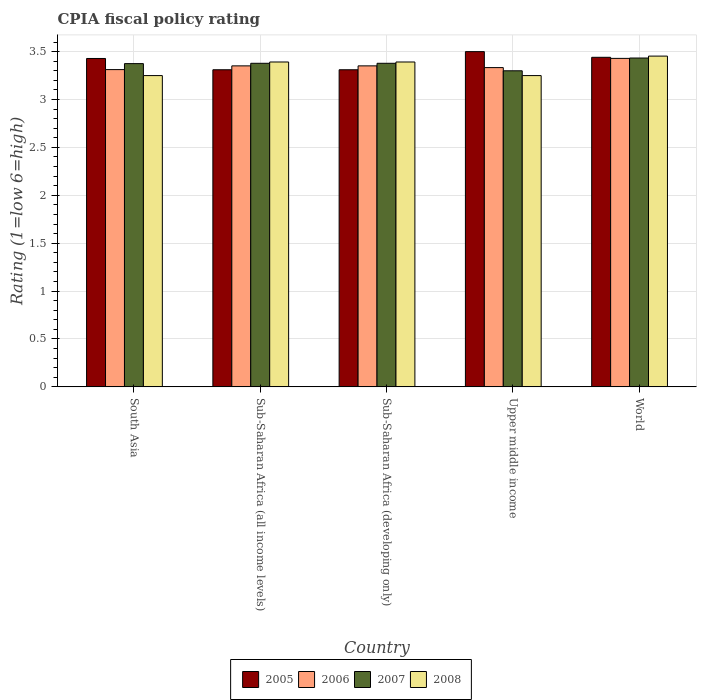Are the number of bars on each tick of the X-axis equal?
Ensure brevity in your answer.  Yes. What is the CPIA rating in 2007 in Sub-Saharan Africa (developing only)?
Offer a very short reply. 3.38. Across all countries, what is the maximum CPIA rating in 2006?
Ensure brevity in your answer.  3.43. Across all countries, what is the minimum CPIA rating in 2005?
Make the answer very short. 3.31. In which country was the CPIA rating in 2006 maximum?
Provide a succinct answer. World. In which country was the CPIA rating in 2007 minimum?
Make the answer very short. Upper middle income. What is the total CPIA rating in 2008 in the graph?
Your answer should be very brief. 16.74. What is the difference between the CPIA rating in 2006 in South Asia and that in Upper middle income?
Your answer should be very brief. -0.02. What is the difference between the CPIA rating in 2006 in Sub-Saharan Africa (developing only) and the CPIA rating in 2005 in World?
Make the answer very short. -0.09. What is the average CPIA rating in 2006 per country?
Your response must be concise. 3.36. What is the difference between the CPIA rating of/in 2005 and CPIA rating of/in 2006 in World?
Offer a very short reply. 0.01. What is the ratio of the CPIA rating in 2007 in South Asia to that in Sub-Saharan Africa (all income levels)?
Make the answer very short. 1. Is the CPIA rating in 2005 in South Asia less than that in Sub-Saharan Africa (all income levels)?
Provide a succinct answer. No. Is the difference between the CPIA rating in 2005 in Sub-Saharan Africa (all income levels) and World greater than the difference between the CPIA rating in 2006 in Sub-Saharan Africa (all income levels) and World?
Make the answer very short. No. What is the difference between the highest and the second highest CPIA rating in 2007?
Keep it short and to the point. -0.05. What is the difference between the highest and the lowest CPIA rating in 2006?
Give a very brief answer. 0.12. In how many countries, is the CPIA rating in 2005 greater than the average CPIA rating in 2005 taken over all countries?
Provide a short and direct response. 3. Is it the case that in every country, the sum of the CPIA rating in 2007 and CPIA rating in 2005 is greater than the sum of CPIA rating in 2008 and CPIA rating in 2006?
Provide a succinct answer. No. Are the values on the major ticks of Y-axis written in scientific E-notation?
Provide a succinct answer. No. Does the graph contain any zero values?
Your answer should be very brief. No. Where does the legend appear in the graph?
Offer a very short reply. Bottom center. How are the legend labels stacked?
Offer a very short reply. Horizontal. What is the title of the graph?
Your answer should be compact. CPIA fiscal policy rating. What is the label or title of the Y-axis?
Give a very brief answer. Rating (1=low 6=high). What is the Rating (1=low 6=high) of 2005 in South Asia?
Offer a terse response. 3.43. What is the Rating (1=low 6=high) in 2006 in South Asia?
Your response must be concise. 3.31. What is the Rating (1=low 6=high) of 2007 in South Asia?
Provide a succinct answer. 3.38. What is the Rating (1=low 6=high) in 2005 in Sub-Saharan Africa (all income levels)?
Keep it short and to the point. 3.31. What is the Rating (1=low 6=high) of 2006 in Sub-Saharan Africa (all income levels)?
Offer a terse response. 3.35. What is the Rating (1=low 6=high) of 2007 in Sub-Saharan Africa (all income levels)?
Your response must be concise. 3.38. What is the Rating (1=low 6=high) of 2008 in Sub-Saharan Africa (all income levels)?
Give a very brief answer. 3.39. What is the Rating (1=low 6=high) in 2005 in Sub-Saharan Africa (developing only)?
Provide a succinct answer. 3.31. What is the Rating (1=low 6=high) of 2006 in Sub-Saharan Africa (developing only)?
Offer a very short reply. 3.35. What is the Rating (1=low 6=high) in 2007 in Sub-Saharan Africa (developing only)?
Give a very brief answer. 3.38. What is the Rating (1=low 6=high) in 2008 in Sub-Saharan Africa (developing only)?
Make the answer very short. 3.39. What is the Rating (1=low 6=high) in 2005 in Upper middle income?
Provide a short and direct response. 3.5. What is the Rating (1=low 6=high) in 2006 in Upper middle income?
Provide a short and direct response. 3.33. What is the Rating (1=low 6=high) in 2008 in Upper middle income?
Provide a short and direct response. 3.25. What is the Rating (1=low 6=high) of 2005 in World?
Ensure brevity in your answer.  3.44. What is the Rating (1=low 6=high) of 2006 in World?
Provide a succinct answer. 3.43. What is the Rating (1=low 6=high) in 2007 in World?
Offer a terse response. 3.43. What is the Rating (1=low 6=high) in 2008 in World?
Your answer should be compact. 3.45. Across all countries, what is the maximum Rating (1=low 6=high) in 2005?
Keep it short and to the point. 3.5. Across all countries, what is the maximum Rating (1=low 6=high) in 2006?
Make the answer very short. 3.43. Across all countries, what is the maximum Rating (1=low 6=high) of 2007?
Your response must be concise. 3.43. Across all countries, what is the maximum Rating (1=low 6=high) in 2008?
Keep it short and to the point. 3.45. Across all countries, what is the minimum Rating (1=low 6=high) of 2005?
Your response must be concise. 3.31. Across all countries, what is the minimum Rating (1=low 6=high) of 2006?
Your response must be concise. 3.31. Across all countries, what is the minimum Rating (1=low 6=high) of 2007?
Provide a succinct answer. 3.3. What is the total Rating (1=low 6=high) in 2005 in the graph?
Offer a very short reply. 16.99. What is the total Rating (1=low 6=high) of 2006 in the graph?
Keep it short and to the point. 16.78. What is the total Rating (1=low 6=high) in 2007 in the graph?
Give a very brief answer. 16.87. What is the total Rating (1=low 6=high) in 2008 in the graph?
Offer a very short reply. 16.74. What is the difference between the Rating (1=low 6=high) of 2005 in South Asia and that in Sub-Saharan Africa (all income levels)?
Your answer should be very brief. 0.12. What is the difference between the Rating (1=low 6=high) of 2006 in South Asia and that in Sub-Saharan Africa (all income levels)?
Your answer should be compact. -0.04. What is the difference between the Rating (1=low 6=high) in 2007 in South Asia and that in Sub-Saharan Africa (all income levels)?
Your response must be concise. -0. What is the difference between the Rating (1=low 6=high) in 2008 in South Asia and that in Sub-Saharan Africa (all income levels)?
Provide a succinct answer. -0.14. What is the difference between the Rating (1=low 6=high) of 2005 in South Asia and that in Sub-Saharan Africa (developing only)?
Your answer should be very brief. 0.12. What is the difference between the Rating (1=low 6=high) in 2006 in South Asia and that in Sub-Saharan Africa (developing only)?
Offer a terse response. -0.04. What is the difference between the Rating (1=low 6=high) in 2007 in South Asia and that in Sub-Saharan Africa (developing only)?
Make the answer very short. -0. What is the difference between the Rating (1=low 6=high) in 2008 in South Asia and that in Sub-Saharan Africa (developing only)?
Your response must be concise. -0.14. What is the difference between the Rating (1=low 6=high) in 2005 in South Asia and that in Upper middle income?
Provide a short and direct response. -0.07. What is the difference between the Rating (1=low 6=high) of 2006 in South Asia and that in Upper middle income?
Your answer should be very brief. -0.02. What is the difference between the Rating (1=low 6=high) of 2007 in South Asia and that in Upper middle income?
Offer a terse response. 0.07. What is the difference between the Rating (1=low 6=high) in 2005 in South Asia and that in World?
Provide a short and direct response. -0.01. What is the difference between the Rating (1=low 6=high) in 2006 in South Asia and that in World?
Your response must be concise. -0.12. What is the difference between the Rating (1=low 6=high) in 2007 in South Asia and that in World?
Offer a terse response. -0.06. What is the difference between the Rating (1=low 6=high) of 2008 in South Asia and that in World?
Offer a terse response. -0.2. What is the difference between the Rating (1=low 6=high) of 2005 in Sub-Saharan Africa (all income levels) and that in Sub-Saharan Africa (developing only)?
Your answer should be very brief. 0. What is the difference between the Rating (1=low 6=high) of 2006 in Sub-Saharan Africa (all income levels) and that in Sub-Saharan Africa (developing only)?
Your response must be concise. 0. What is the difference between the Rating (1=low 6=high) in 2008 in Sub-Saharan Africa (all income levels) and that in Sub-Saharan Africa (developing only)?
Offer a very short reply. 0. What is the difference between the Rating (1=low 6=high) in 2005 in Sub-Saharan Africa (all income levels) and that in Upper middle income?
Offer a terse response. -0.19. What is the difference between the Rating (1=low 6=high) in 2006 in Sub-Saharan Africa (all income levels) and that in Upper middle income?
Offer a terse response. 0.02. What is the difference between the Rating (1=low 6=high) in 2007 in Sub-Saharan Africa (all income levels) and that in Upper middle income?
Keep it short and to the point. 0.08. What is the difference between the Rating (1=low 6=high) in 2008 in Sub-Saharan Africa (all income levels) and that in Upper middle income?
Your response must be concise. 0.14. What is the difference between the Rating (1=low 6=high) of 2005 in Sub-Saharan Africa (all income levels) and that in World?
Offer a very short reply. -0.13. What is the difference between the Rating (1=low 6=high) of 2006 in Sub-Saharan Africa (all income levels) and that in World?
Offer a very short reply. -0.08. What is the difference between the Rating (1=low 6=high) of 2007 in Sub-Saharan Africa (all income levels) and that in World?
Offer a very short reply. -0.06. What is the difference between the Rating (1=low 6=high) in 2008 in Sub-Saharan Africa (all income levels) and that in World?
Offer a terse response. -0.06. What is the difference between the Rating (1=low 6=high) in 2005 in Sub-Saharan Africa (developing only) and that in Upper middle income?
Provide a short and direct response. -0.19. What is the difference between the Rating (1=low 6=high) in 2006 in Sub-Saharan Africa (developing only) and that in Upper middle income?
Provide a short and direct response. 0.02. What is the difference between the Rating (1=low 6=high) of 2007 in Sub-Saharan Africa (developing only) and that in Upper middle income?
Offer a very short reply. 0.08. What is the difference between the Rating (1=low 6=high) of 2008 in Sub-Saharan Africa (developing only) and that in Upper middle income?
Keep it short and to the point. 0.14. What is the difference between the Rating (1=low 6=high) in 2005 in Sub-Saharan Africa (developing only) and that in World?
Provide a short and direct response. -0.13. What is the difference between the Rating (1=low 6=high) in 2006 in Sub-Saharan Africa (developing only) and that in World?
Offer a terse response. -0.08. What is the difference between the Rating (1=low 6=high) in 2007 in Sub-Saharan Africa (developing only) and that in World?
Make the answer very short. -0.06. What is the difference between the Rating (1=low 6=high) in 2008 in Sub-Saharan Africa (developing only) and that in World?
Offer a terse response. -0.06. What is the difference between the Rating (1=low 6=high) in 2005 in Upper middle income and that in World?
Offer a very short reply. 0.06. What is the difference between the Rating (1=low 6=high) of 2006 in Upper middle income and that in World?
Provide a succinct answer. -0.1. What is the difference between the Rating (1=low 6=high) of 2007 in Upper middle income and that in World?
Ensure brevity in your answer.  -0.13. What is the difference between the Rating (1=low 6=high) of 2008 in Upper middle income and that in World?
Provide a succinct answer. -0.2. What is the difference between the Rating (1=low 6=high) of 2005 in South Asia and the Rating (1=low 6=high) of 2006 in Sub-Saharan Africa (all income levels)?
Give a very brief answer. 0.08. What is the difference between the Rating (1=low 6=high) of 2005 in South Asia and the Rating (1=low 6=high) of 2007 in Sub-Saharan Africa (all income levels)?
Offer a very short reply. 0.05. What is the difference between the Rating (1=low 6=high) of 2005 in South Asia and the Rating (1=low 6=high) of 2008 in Sub-Saharan Africa (all income levels)?
Make the answer very short. 0.04. What is the difference between the Rating (1=low 6=high) in 2006 in South Asia and the Rating (1=low 6=high) in 2007 in Sub-Saharan Africa (all income levels)?
Provide a short and direct response. -0.07. What is the difference between the Rating (1=low 6=high) in 2006 in South Asia and the Rating (1=low 6=high) in 2008 in Sub-Saharan Africa (all income levels)?
Your answer should be very brief. -0.08. What is the difference between the Rating (1=low 6=high) of 2007 in South Asia and the Rating (1=low 6=high) of 2008 in Sub-Saharan Africa (all income levels)?
Provide a succinct answer. -0.02. What is the difference between the Rating (1=low 6=high) in 2005 in South Asia and the Rating (1=low 6=high) in 2006 in Sub-Saharan Africa (developing only)?
Provide a succinct answer. 0.08. What is the difference between the Rating (1=low 6=high) in 2005 in South Asia and the Rating (1=low 6=high) in 2007 in Sub-Saharan Africa (developing only)?
Your answer should be very brief. 0.05. What is the difference between the Rating (1=low 6=high) of 2005 in South Asia and the Rating (1=low 6=high) of 2008 in Sub-Saharan Africa (developing only)?
Make the answer very short. 0.04. What is the difference between the Rating (1=low 6=high) in 2006 in South Asia and the Rating (1=low 6=high) in 2007 in Sub-Saharan Africa (developing only)?
Provide a succinct answer. -0.07. What is the difference between the Rating (1=low 6=high) in 2006 in South Asia and the Rating (1=low 6=high) in 2008 in Sub-Saharan Africa (developing only)?
Make the answer very short. -0.08. What is the difference between the Rating (1=low 6=high) in 2007 in South Asia and the Rating (1=low 6=high) in 2008 in Sub-Saharan Africa (developing only)?
Your response must be concise. -0.02. What is the difference between the Rating (1=low 6=high) of 2005 in South Asia and the Rating (1=low 6=high) of 2006 in Upper middle income?
Give a very brief answer. 0.1. What is the difference between the Rating (1=low 6=high) of 2005 in South Asia and the Rating (1=low 6=high) of 2007 in Upper middle income?
Ensure brevity in your answer.  0.13. What is the difference between the Rating (1=low 6=high) of 2005 in South Asia and the Rating (1=low 6=high) of 2008 in Upper middle income?
Ensure brevity in your answer.  0.18. What is the difference between the Rating (1=low 6=high) of 2006 in South Asia and the Rating (1=low 6=high) of 2007 in Upper middle income?
Provide a short and direct response. 0.01. What is the difference between the Rating (1=low 6=high) of 2006 in South Asia and the Rating (1=low 6=high) of 2008 in Upper middle income?
Your response must be concise. 0.06. What is the difference between the Rating (1=low 6=high) of 2005 in South Asia and the Rating (1=low 6=high) of 2006 in World?
Ensure brevity in your answer.  -0. What is the difference between the Rating (1=low 6=high) in 2005 in South Asia and the Rating (1=low 6=high) in 2007 in World?
Your answer should be very brief. -0. What is the difference between the Rating (1=low 6=high) in 2005 in South Asia and the Rating (1=low 6=high) in 2008 in World?
Ensure brevity in your answer.  -0.02. What is the difference between the Rating (1=low 6=high) in 2006 in South Asia and the Rating (1=low 6=high) in 2007 in World?
Provide a short and direct response. -0.12. What is the difference between the Rating (1=low 6=high) of 2006 in South Asia and the Rating (1=low 6=high) of 2008 in World?
Offer a terse response. -0.14. What is the difference between the Rating (1=low 6=high) in 2007 in South Asia and the Rating (1=low 6=high) in 2008 in World?
Provide a short and direct response. -0.08. What is the difference between the Rating (1=low 6=high) in 2005 in Sub-Saharan Africa (all income levels) and the Rating (1=low 6=high) in 2006 in Sub-Saharan Africa (developing only)?
Make the answer very short. -0.04. What is the difference between the Rating (1=low 6=high) of 2005 in Sub-Saharan Africa (all income levels) and the Rating (1=low 6=high) of 2007 in Sub-Saharan Africa (developing only)?
Provide a short and direct response. -0.07. What is the difference between the Rating (1=low 6=high) in 2005 in Sub-Saharan Africa (all income levels) and the Rating (1=low 6=high) in 2008 in Sub-Saharan Africa (developing only)?
Your response must be concise. -0.08. What is the difference between the Rating (1=low 6=high) in 2006 in Sub-Saharan Africa (all income levels) and the Rating (1=low 6=high) in 2007 in Sub-Saharan Africa (developing only)?
Ensure brevity in your answer.  -0.03. What is the difference between the Rating (1=low 6=high) of 2006 in Sub-Saharan Africa (all income levels) and the Rating (1=low 6=high) of 2008 in Sub-Saharan Africa (developing only)?
Ensure brevity in your answer.  -0.04. What is the difference between the Rating (1=low 6=high) of 2007 in Sub-Saharan Africa (all income levels) and the Rating (1=low 6=high) of 2008 in Sub-Saharan Africa (developing only)?
Ensure brevity in your answer.  -0.01. What is the difference between the Rating (1=low 6=high) of 2005 in Sub-Saharan Africa (all income levels) and the Rating (1=low 6=high) of 2006 in Upper middle income?
Make the answer very short. -0.02. What is the difference between the Rating (1=low 6=high) of 2005 in Sub-Saharan Africa (all income levels) and the Rating (1=low 6=high) of 2007 in Upper middle income?
Provide a short and direct response. 0.01. What is the difference between the Rating (1=low 6=high) in 2005 in Sub-Saharan Africa (all income levels) and the Rating (1=low 6=high) in 2008 in Upper middle income?
Provide a succinct answer. 0.06. What is the difference between the Rating (1=low 6=high) in 2006 in Sub-Saharan Africa (all income levels) and the Rating (1=low 6=high) in 2007 in Upper middle income?
Keep it short and to the point. 0.05. What is the difference between the Rating (1=low 6=high) of 2006 in Sub-Saharan Africa (all income levels) and the Rating (1=low 6=high) of 2008 in Upper middle income?
Your answer should be compact. 0.1. What is the difference between the Rating (1=low 6=high) in 2007 in Sub-Saharan Africa (all income levels) and the Rating (1=low 6=high) in 2008 in Upper middle income?
Ensure brevity in your answer.  0.13. What is the difference between the Rating (1=low 6=high) in 2005 in Sub-Saharan Africa (all income levels) and the Rating (1=low 6=high) in 2006 in World?
Provide a succinct answer. -0.12. What is the difference between the Rating (1=low 6=high) in 2005 in Sub-Saharan Africa (all income levels) and the Rating (1=low 6=high) in 2007 in World?
Offer a terse response. -0.12. What is the difference between the Rating (1=low 6=high) of 2005 in Sub-Saharan Africa (all income levels) and the Rating (1=low 6=high) of 2008 in World?
Keep it short and to the point. -0.14. What is the difference between the Rating (1=low 6=high) of 2006 in Sub-Saharan Africa (all income levels) and the Rating (1=low 6=high) of 2007 in World?
Offer a very short reply. -0.08. What is the difference between the Rating (1=low 6=high) in 2006 in Sub-Saharan Africa (all income levels) and the Rating (1=low 6=high) in 2008 in World?
Your response must be concise. -0.1. What is the difference between the Rating (1=low 6=high) of 2007 in Sub-Saharan Africa (all income levels) and the Rating (1=low 6=high) of 2008 in World?
Your response must be concise. -0.07. What is the difference between the Rating (1=low 6=high) in 2005 in Sub-Saharan Africa (developing only) and the Rating (1=low 6=high) in 2006 in Upper middle income?
Make the answer very short. -0.02. What is the difference between the Rating (1=low 6=high) of 2005 in Sub-Saharan Africa (developing only) and the Rating (1=low 6=high) of 2007 in Upper middle income?
Offer a very short reply. 0.01. What is the difference between the Rating (1=low 6=high) of 2005 in Sub-Saharan Africa (developing only) and the Rating (1=low 6=high) of 2008 in Upper middle income?
Offer a very short reply. 0.06. What is the difference between the Rating (1=low 6=high) of 2006 in Sub-Saharan Africa (developing only) and the Rating (1=low 6=high) of 2007 in Upper middle income?
Give a very brief answer. 0.05. What is the difference between the Rating (1=low 6=high) of 2006 in Sub-Saharan Africa (developing only) and the Rating (1=low 6=high) of 2008 in Upper middle income?
Give a very brief answer. 0.1. What is the difference between the Rating (1=low 6=high) of 2007 in Sub-Saharan Africa (developing only) and the Rating (1=low 6=high) of 2008 in Upper middle income?
Offer a very short reply. 0.13. What is the difference between the Rating (1=low 6=high) in 2005 in Sub-Saharan Africa (developing only) and the Rating (1=low 6=high) in 2006 in World?
Offer a terse response. -0.12. What is the difference between the Rating (1=low 6=high) of 2005 in Sub-Saharan Africa (developing only) and the Rating (1=low 6=high) of 2007 in World?
Provide a succinct answer. -0.12. What is the difference between the Rating (1=low 6=high) of 2005 in Sub-Saharan Africa (developing only) and the Rating (1=low 6=high) of 2008 in World?
Your answer should be compact. -0.14. What is the difference between the Rating (1=low 6=high) in 2006 in Sub-Saharan Africa (developing only) and the Rating (1=low 6=high) in 2007 in World?
Your answer should be very brief. -0.08. What is the difference between the Rating (1=low 6=high) in 2006 in Sub-Saharan Africa (developing only) and the Rating (1=low 6=high) in 2008 in World?
Your response must be concise. -0.1. What is the difference between the Rating (1=low 6=high) in 2007 in Sub-Saharan Africa (developing only) and the Rating (1=low 6=high) in 2008 in World?
Keep it short and to the point. -0.07. What is the difference between the Rating (1=low 6=high) in 2005 in Upper middle income and the Rating (1=low 6=high) in 2006 in World?
Your answer should be compact. 0.07. What is the difference between the Rating (1=low 6=high) in 2005 in Upper middle income and the Rating (1=low 6=high) in 2007 in World?
Your response must be concise. 0.07. What is the difference between the Rating (1=low 6=high) of 2005 in Upper middle income and the Rating (1=low 6=high) of 2008 in World?
Offer a terse response. 0.05. What is the difference between the Rating (1=low 6=high) of 2006 in Upper middle income and the Rating (1=low 6=high) of 2008 in World?
Make the answer very short. -0.12. What is the difference between the Rating (1=low 6=high) in 2007 in Upper middle income and the Rating (1=low 6=high) in 2008 in World?
Offer a very short reply. -0.15. What is the average Rating (1=low 6=high) of 2005 per country?
Provide a succinct answer. 3.4. What is the average Rating (1=low 6=high) in 2006 per country?
Offer a terse response. 3.36. What is the average Rating (1=low 6=high) in 2007 per country?
Provide a short and direct response. 3.37. What is the average Rating (1=low 6=high) of 2008 per country?
Give a very brief answer. 3.35. What is the difference between the Rating (1=low 6=high) in 2005 and Rating (1=low 6=high) in 2006 in South Asia?
Give a very brief answer. 0.12. What is the difference between the Rating (1=low 6=high) of 2005 and Rating (1=low 6=high) of 2007 in South Asia?
Your answer should be compact. 0.05. What is the difference between the Rating (1=low 6=high) of 2005 and Rating (1=low 6=high) of 2008 in South Asia?
Keep it short and to the point. 0.18. What is the difference between the Rating (1=low 6=high) of 2006 and Rating (1=low 6=high) of 2007 in South Asia?
Your response must be concise. -0.06. What is the difference between the Rating (1=low 6=high) of 2006 and Rating (1=low 6=high) of 2008 in South Asia?
Offer a terse response. 0.06. What is the difference between the Rating (1=low 6=high) of 2007 and Rating (1=low 6=high) of 2008 in South Asia?
Offer a very short reply. 0.12. What is the difference between the Rating (1=low 6=high) in 2005 and Rating (1=low 6=high) in 2006 in Sub-Saharan Africa (all income levels)?
Ensure brevity in your answer.  -0.04. What is the difference between the Rating (1=low 6=high) of 2005 and Rating (1=low 6=high) of 2007 in Sub-Saharan Africa (all income levels)?
Give a very brief answer. -0.07. What is the difference between the Rating (1=low 6=high) in 2005 and Rating (1=low 6=high) in 2008 in Sub-Saharan Africa (all income levels)?
Provide a succinct answer. -0.08. What is the difference between the Rating (1=low 6=high) of 2006 and Rating (1=low 6=high) of 2007 in Sub-Saharan Africa (all income levels)?
Provide a succinct answer. -0.03. What is the difference between the Rating (1=low 6=high) of 2006 and Rating (1=low 6=high) of 2008 in Sub-Saharan Africa (all income levels)?
Offer a very short reply. -0.04. What is the difference between the Rating (1=low 6=high) of 2007 and Rating (1=low 6=high) of 2008 in Sub-Saharan Africa (all income levels)?
Provide a short and direct response. -0.01. What is the difference between the Rating (1=low 6=high) of 2005 and Rating (1=low 6=high) of 2006 in Sub-Saharan Africa (developing only)?
Offer a terse response. -0.04. What is the difference between the Rating (1=low 6=high) in 2005 and Rating (1=low 6=high) in 2007 in Sub-Saharan Africa (developing only)?
Provide a short and direct response. -0.07. What is the difference between the Rating (1=low 6=high) of 2005 and Rating (1=low 6=high) of 2008 in Sub-Saharan Africa (developing only)?
Keep it short and to the point. -0.08. What is the difference between the Rating (1=low 6=high) of 2006 and Rating (1=low 6=high) of 2007 in Sub-Saharan Africa (developing only)?
Your answer should be very brief. -0.03. What is the difference between the Rating (1=low 6=high) of 2006 and Rating (1=low 6=high) of 2008 in Sub-Saharan Africa (developing only)?
Make the answer very short. -0.04. What is the difference between the Rating (1=low 6=high) of 2007 and Rating (1=low 6=high) of 2008 in Sub-Saharan Africa (developing only)?
Provide a short and direct response. -0.01. What is the difference between the Rating (1=low 6=high) in 2005 and Rating (1=low 6=high) in 2007 in Upper middle income?
Keep it short and to the point. 0.2. What is the difference between the Rating (1=low 6=high) of 2006 and Rating (1=low 6=high) of 2008 in Upper middle income?
Your answer should be very brief. 0.08. What is the difference between the Rating (1=low 6=high) of 2005 and Rating (1=low 6=high) of 2006 in World?
Your response must be concise. 0.01. What is the difference between the Rating (1=low 6=high) of 2005 and Rating (1=low 6=high) of 2007 in World?
Keep it short and to the point. 0.01. What is the difference between the Rating (1=low 6=high) in 2005 and Rating (1=low 6=high) in 2008 in World?
Make the answer very short. -0.01. What is the difference between the Rating (1=low 6=high) of 2006 and Rating (1=low 6=high) of 2007 in World?
Keep it short and to the point. -0. What is the difference between the Rating (1=low 6=high) in 2006 and Rating (1=low 6=high) in 2008 in World?
Provide a succinct answer. -0.02. What is the difference between the Rating (1=low 6=high) in 2007 and Rating (1=low 6=high) in 2008 in World?
Provide a succinct answer. -0.02. What is the ratio of the Rating (1=low 6=high) in 2005 in South Asia to that in Sub-Saharan Africa (all income levels)?
Your response must be concise. 1.04. What is the ratio of the Rating (1=low 6=high) of 2006 in South Asia to that in Sub-Saharan Africa (all income levels)?
Ensure brevity in your answer.  0.99. What is the ratio of the Rating (1=low 6=high) of 2008 in South Asia to that in Sub-Saharan Africa (all income levels)?
Offer a terse response. 0.96. What is the ratio of the Rating (1=low 6=high) of 2005 in South Asia to that in Sub-Saharan Africa (developing only)?
Your answer should be compact. 1.04. What is the ratio of the Rating (1=low 6=high) of 2006 in South Asia to that in Sub-Saharan Africa (developing only)?
Provide a short and direct response. 0.99. What is the ratio of the Rating (1=low 6=high) of 2007 in South Asia to that in Sub-Saharan Africa (developing only)?
Your answer should be compact. 1. What is the ratio of the Rating (1=low 6=high) of 2008 in South Asia to that in Sub-Saharan Africa (developing only)?
Offer a terse response. 0.96. What is the ratio of the Rating (1=low 6=high) of 2005 in South Asia to that in Upper middle income?
Offer a terse response. 0.98. What is the ratio of the Rating (1=low 6=high) of 2007 in South Asia to that in Upper middle income?
Keep it short and to the point. 1.02. What is the ratio of the Rating (1=low 6=high) of 2005 in South Asia to that in World?
Offer a very short reply. 1. What is the ratio of the Rating (1=low 6=high) in 2006 in South Asia to that in World?
Make the answer very short. 0.97. What is the ratio of the Rating (1=low 6=high) of 2007 in South Asia to that in World?
Offer a terse response. 0.98. What is the ratio of the Rating (1=low 6=high) in 2008 in South Asia to that in World?
Give a very brief answer. 0.94. What is the ratio of the Rating (1=low 6=high) in 2008 in Sub-Saharan Africa (all income levels) to that in Sub-Saharan Africa (developing only)?
Your answer should be compact. 1. What is the ratio of the Rating (1=low 6=high) in 2005 in Sub-Saharan Africa (all income levels) to that in Upper middle income?
Give a very brief answer. 0.95. What is the ratio of the Rating (1=low 6=high) in 2006 in Sub-Saharan Africa (all income levels) to that in Upper middle income?
Make the answer very short. 1.01. What is the ratio of the Rating (1=low 6=high) in 2007 in Sub-Saharan Africa (all income levels) to that in Upper middle income?
Provide a short and direct response. 1.02. What is the ratio of the Rating (1=low 6=high) of 2008 in Sub-Saharan Africa (all income levels) to that in Upper middle income?
Your response must be concise. 1.04. What is the ratio of the Rating (1=low 6=high) in 2005 in Sub-Saharan Africa (all income levels) to that in World?
Give a very brief answer. 0.96. What is the ratio of the Rating (1=low 6=high) of 2006 in Sub-Saharan Africa (all income levels) to that in World?
Your answer should be very brief. 0.98. What is the ratio of the Rating (1=low 6=high) of 2008 in Sub-Saharan Africa (all income levels) to that in World?
Provide a succinct answer. 0.98. What is the ratio of the Rating (1=low 6=high) of 2005 in Sub-Saharan Africa (developing only) to that in Upper middle income?
Provide a short and direct response. 0.95. What is the ratio of the Rating (1=low 6=high) in 2006 in Sub-Saharan Africa (developing only) to that in Upper middle income?
Your response must be concise. 1.01. What is the ratio of the Rating (1=low 6=high) in 2007 in Sub-Saharan Africa (developing only) to that in Upper middle income?
Provide a short and direct response. 1.02. What is the ratio of the Rating (1=low 6=high) in 2008 in Sub-Saharan Africa (developing only) to that in Upper middle income?
Your answer should be compact. 1.04. What is the ratio of the Rating (1=low 6=high) of 2005 in Sub-Saharan Africa (developing only) to that in World?
Your answer should be compact. 0.96. What is the ratio of the Rating (1=low 6=high) of 2006 in Sub-Saharan Africa (developing only) to that in World?
Ensure brevity in your answer.  0.98. What is the ratio of the Rating (1=low 6=high) in 2007 in Sub-Saharan Africa (developing only) to that in World?
Make the answer very short. 0.98. What is the ratio of the Rating (1=low 6=high) in 2008 in Sub-Saharan Africa (developing only) to that in World?
Make the answer very short. 0.98. What is the ratio of the Rating (1=low 6=high) of 2005 in Upper middle income to that in World?
Your response must be concise. 1.02. What is the ratio of the Rating (1=low 6=high) in 2007 in Upper middle income to that in World?
Provide a short and direct response. 0.96. What is the ratio of the Rating (1=low 6=high) of 2008 in Upper middle income to that in World?
Provide a short and direct response. 0.94. What is the difference between the highest and the second highest Rating (1=low 6=high) in 2005?
Provide a succinct answer. 0.06. What is the difference between the highest and the second highest Rating (1=low 6=high) of 2006?
Provide a succinct answer. 0.08. What is the difference between the highest and the second highest Rating (1=low 6=high) of 2007?
Make the answer very short. 0.06. What is the difference between the highest and the second highest Rating (1=low 6=high) of 2008?
Your answer should be compact. 0.06. What is the difference between the highest and the lowest Rating (1=low 6=high) of 2005?
Make the answer very short. 0.19. What is the difference between the highest and the lowest Rating (1=low 6=high) in 2006?
Ensure brevity in your answer.  0.12. What is the difference between the highest and the lowest Rating (1=low 6=high) in 2007?
Keep it short and to the point. 0.13. What is the difference between the highest and the lowest Rating (1=low 6=high) in 2008?
Ensure brevity in your answer.  0.2. 